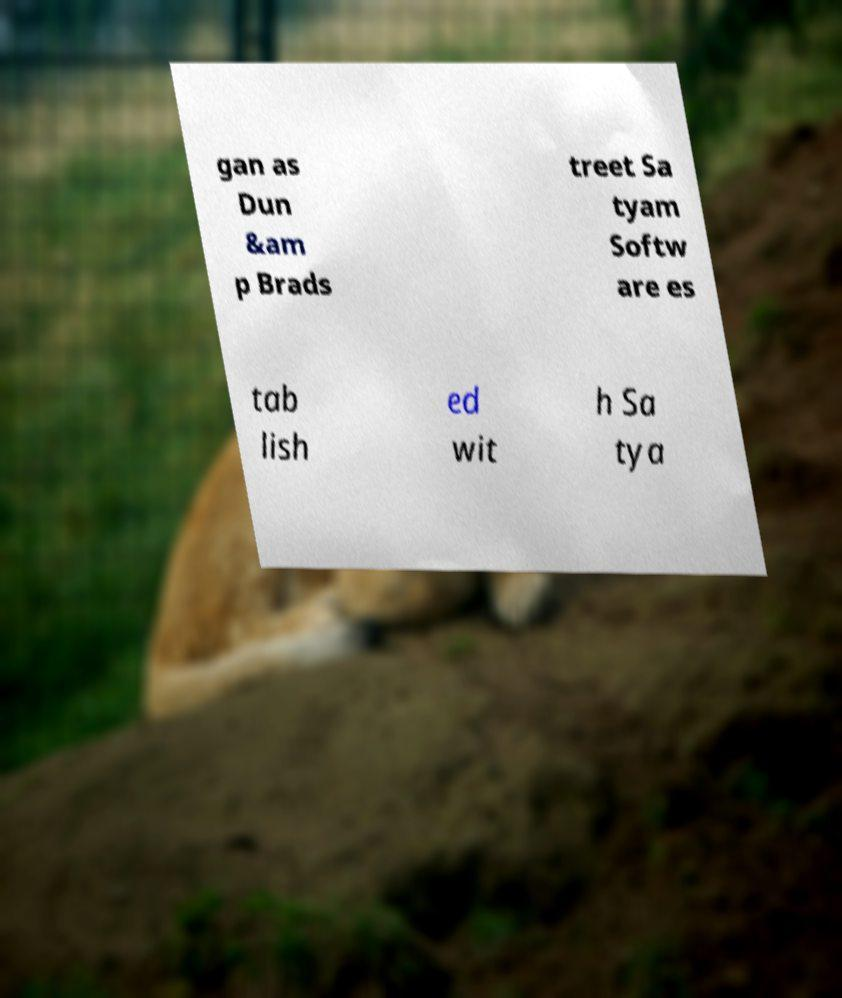Can you read and provide the text displayed in the image?This photo seems to have some interesting text. Can you extract and type it out for me? gan as Dun &am p Brads treet Sa tyam Softw are es tab lish ed wit h Sa tya 